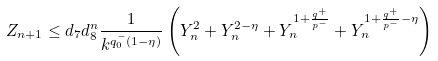<formula> <loc_0><loc_0><loc_500><loc_500>& Z _ { n + 1 } \leq d _ { 7 } d _ { 8 } ^ { n } \frac { 1 } { k ^ { q _ { 0 } ^ { - } ( 1 - \eta ) } } \left ( Y _ { n } ^ { 2 } + Y _ { n } ^ { 2 - \eta } + Y _ { n } ^ { 1 + \frac { q ^ { + } } { p ^ { - } } } + Y _ { n } ^ { 1 + \frac { q ^ { + } } { p ^ { - } } - \eta } \right )</formula> 